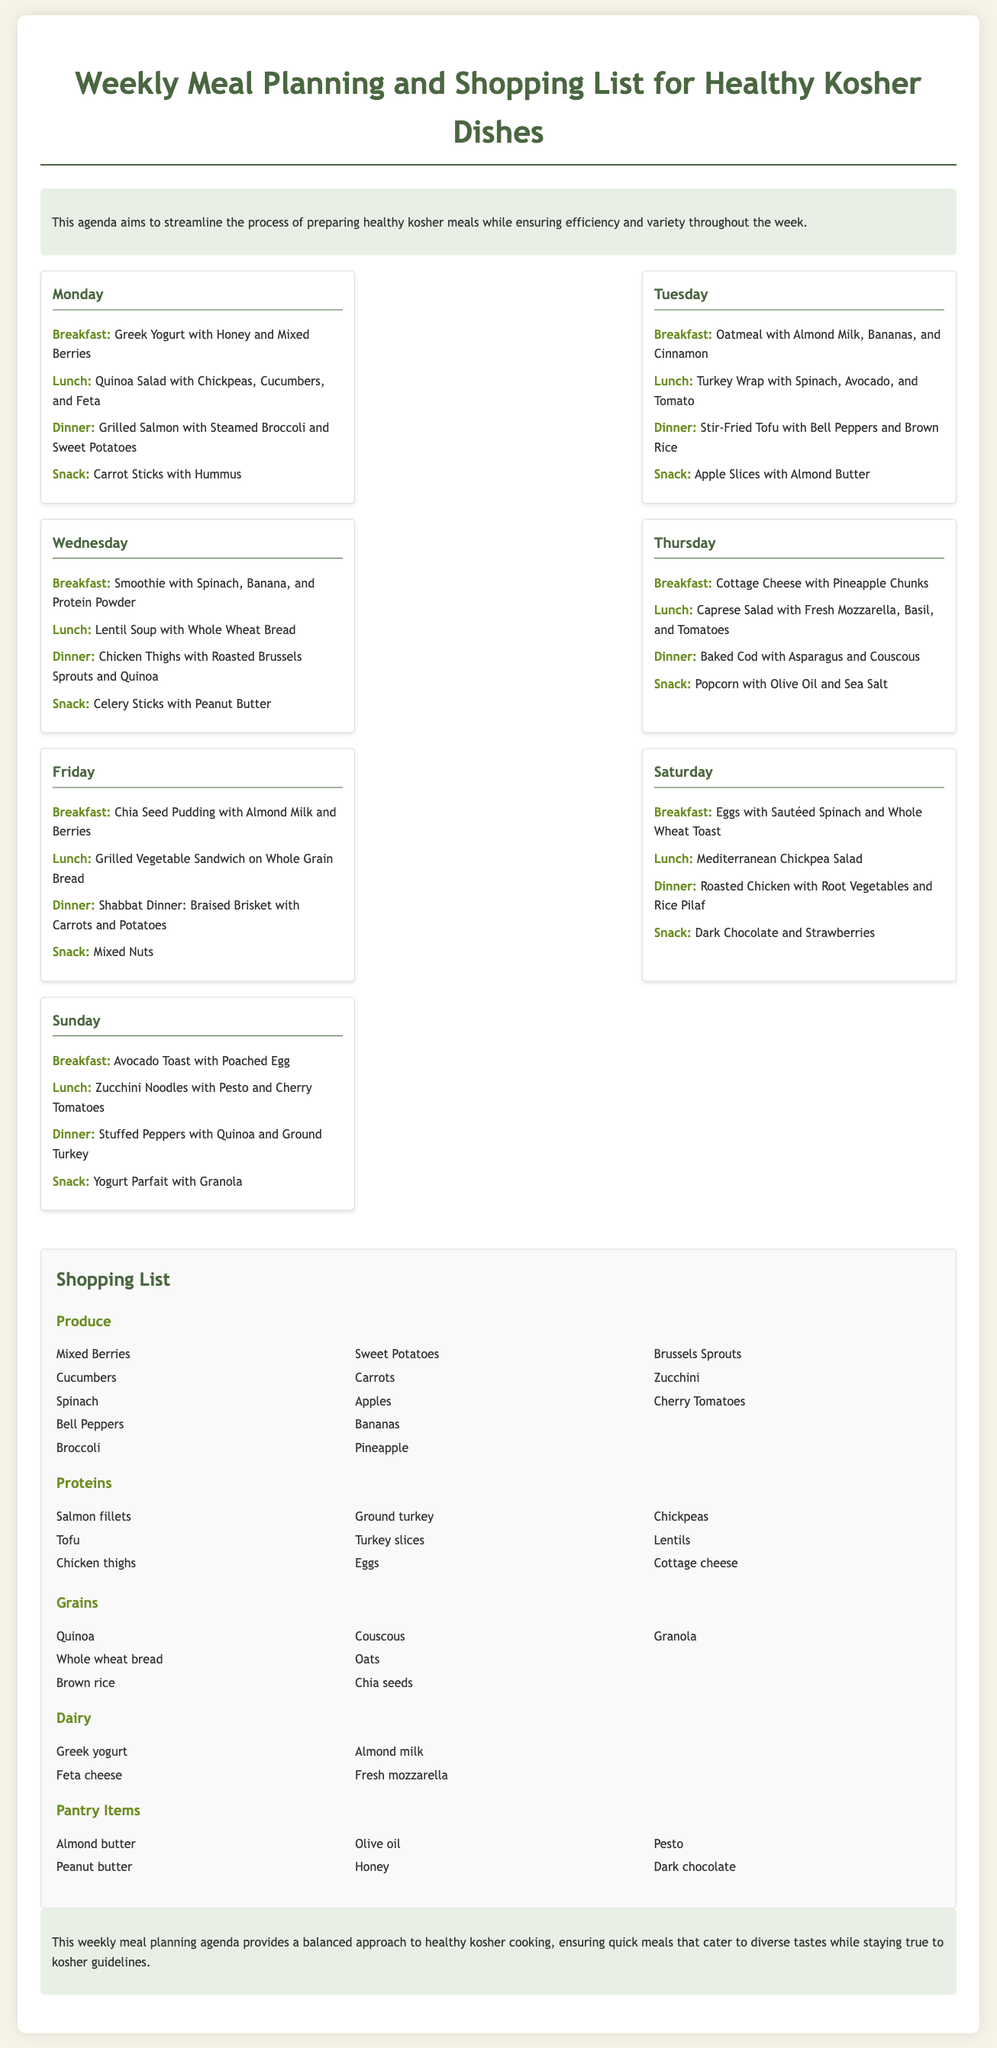What is the main focus of the agenda? The agenda aims to streamline the process of preparing healthy kosher meals.
Answer: healthy kosher meals How many meals are planned for Monday? The document lists a total of four meals for Monday: breakfast, lunch, dinner, and snack.
Answer: 4 What type of protein is included on Tuesday's dinner? The document states that Tuesday's dinner features Stir-Fried Tofu.
Answer: Tofu Which day features Shabbat Dinner? According to the document, Shabbat Dinner is on Friday.
Answer: Friday What is one of the snacks listed for Wednesday? The snack listed for Wednesday is Celery Sticks with Peanut Butter.
Answer: Celery Sticks with Peanut Butter How many different categories are in the shopping list? The shopping list includes five categories: Produce, Proteins, Grains, Dairy, and Pantry Items.
Answer: 5 What fruit is mentioned in the breakfast for Saturday? The breakfast listed for Saturday includes Eggs with Sautéed Spinach and Whole Wheat Toast, and does not mention fruit, but for the snack, dark chocolate and strawberries are listed.
Answer: strawberries What is one ingredient from the grains category? One ingredient listed in the grains category is Quinoa.
Answer: Quinoa What meal type is included in the snack for Sunday? The snack for Sunday is a Yogurt Parfait with Granola.
Answer: Yogurt Parfait with Granola 